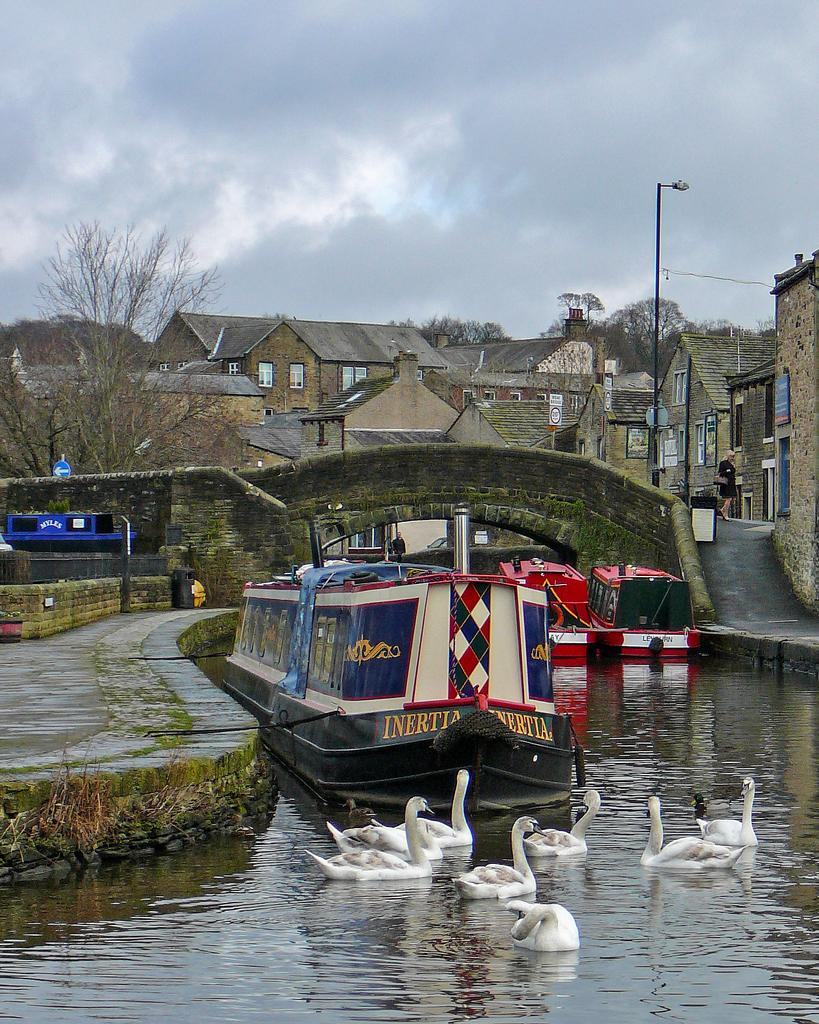What type of vehicles can be seen in the image? There are boats in the image. What structure is present in the image? There is a bridge in the image. What natural element is visible in the image? There is water visible in the image. What type of animals are in the image? There are swans in the image. What type of buildings can be seen in the image? There are houses in the image. What type of man-made object is present in the image? There is a light pole in the image. Who is present in the image? There is a person in the image. What type of signage is present in the image? There are boards in the image, and there is a signboard far away in the image. What type of vegetation is visible in the image? There are trees in the image. What is the condition of the sky in the image? There is a cloudy sky in the image. Where are the rabbits hiding in the image? There are no rabbits present in the image. What type of hook is used by the cook in the image? There is no cook or hook present in the image. 